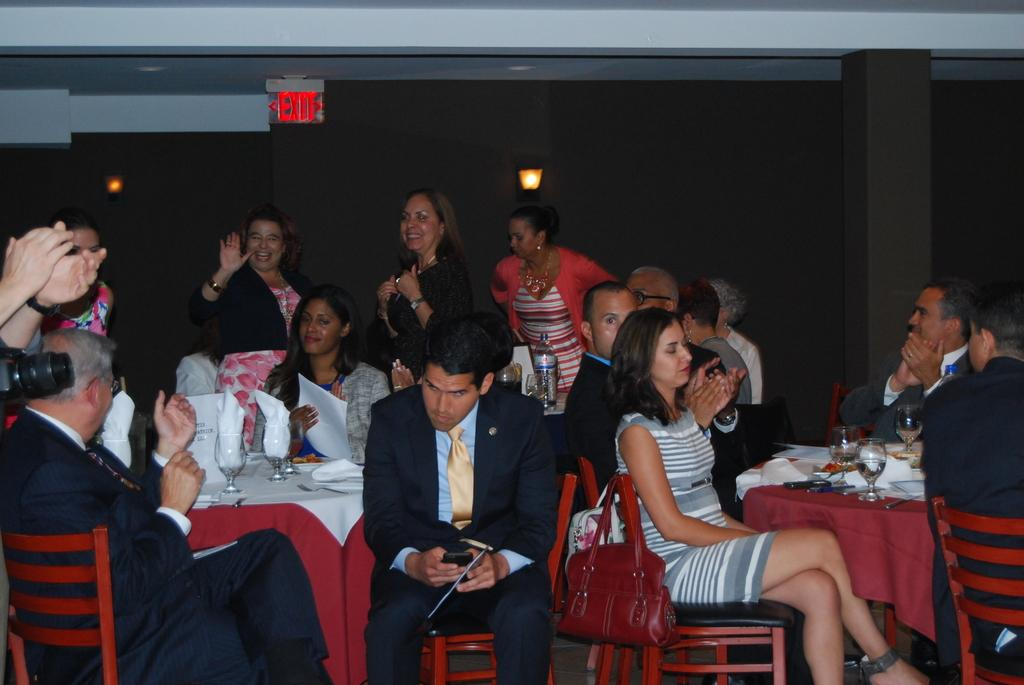Provide a one-sentence caption for the provided image. Several people at an event are sitting right under a red EXIT sign. 